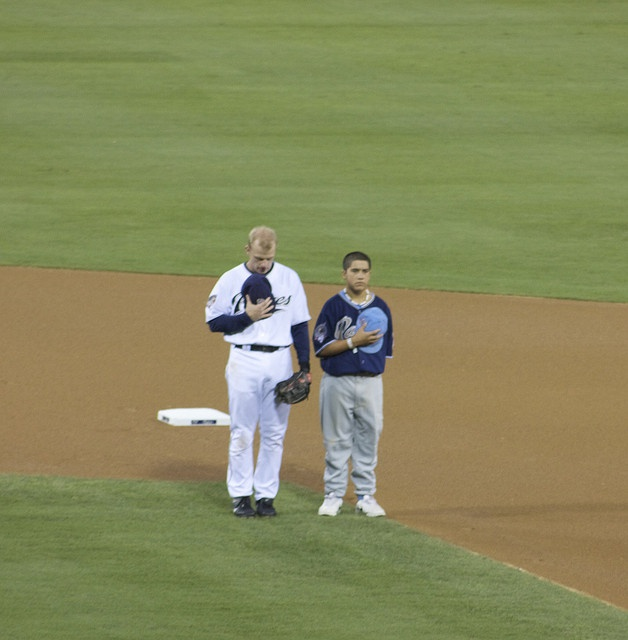Describe the objects in this image and their specific colors. I can see people in olive, lavender, darkgray, black, and gray tones, people in olive, darkgray, navy, tan, and gray tones, and baseball glove in olive, gray, and black tones in this image. 